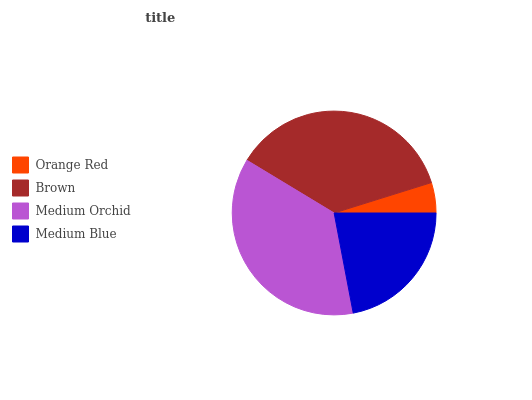Is Orange Red the minimum?
Answer yes or no. Yes. Is Medium Orchid the maximum?
Answer yes or no. Yes. Is Brown the minimum?
Answer yes or no. No. Is Brown the maximum?
Answer yes or no. No. Is Brown greater than Orange Red?
Answer yes or no. Yes. Is Orange Red less than Brown?
Answer yes or no. Yes. Is Orange Red greater than Brown?
Answer yes or no. No. Is Brown less than Orange Red?
Answer yes or no. No. Is Brown the high median?
Answer yes or no. Yes. Is Medium Blue the low median?
Answer yes or no. Yes. Is Medium Blue the high median?
Answer yes or no. No. Is Medium Orchid the low median?
Answer yes or no. No. 